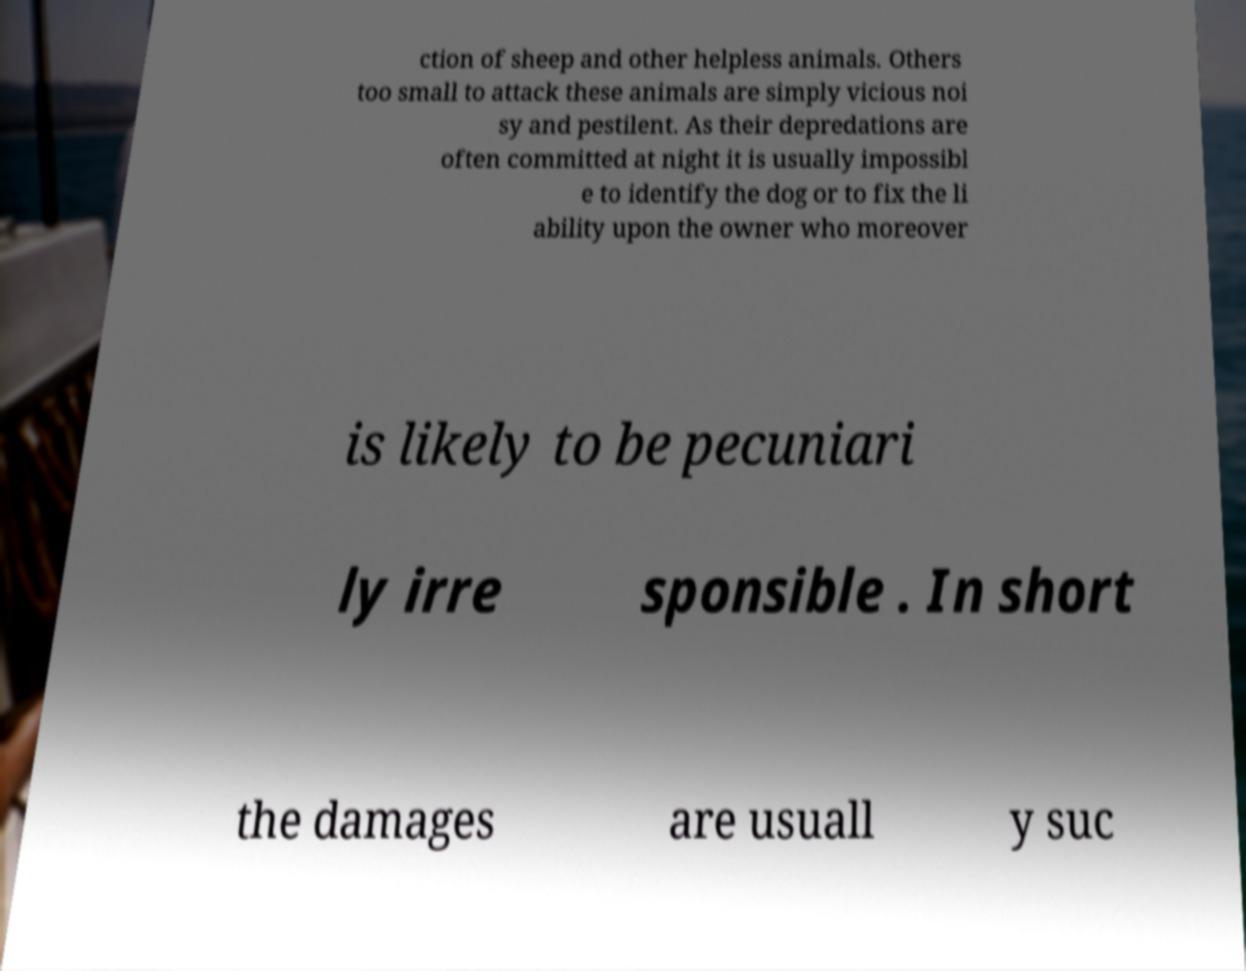For documentation purposes, I need the text within this image transcribed. Could you provide that? ction of sheep and other helpless animals. Others too small to attack these animals are simply vicious noi sy and pestilent. As their depredations are often committed at night it is usually impossibl e to identify the dog or to fix the li ability upon the owner who moreover is likely to be pecuniari ly irre sponsible . In short the damages are usuall y suc 